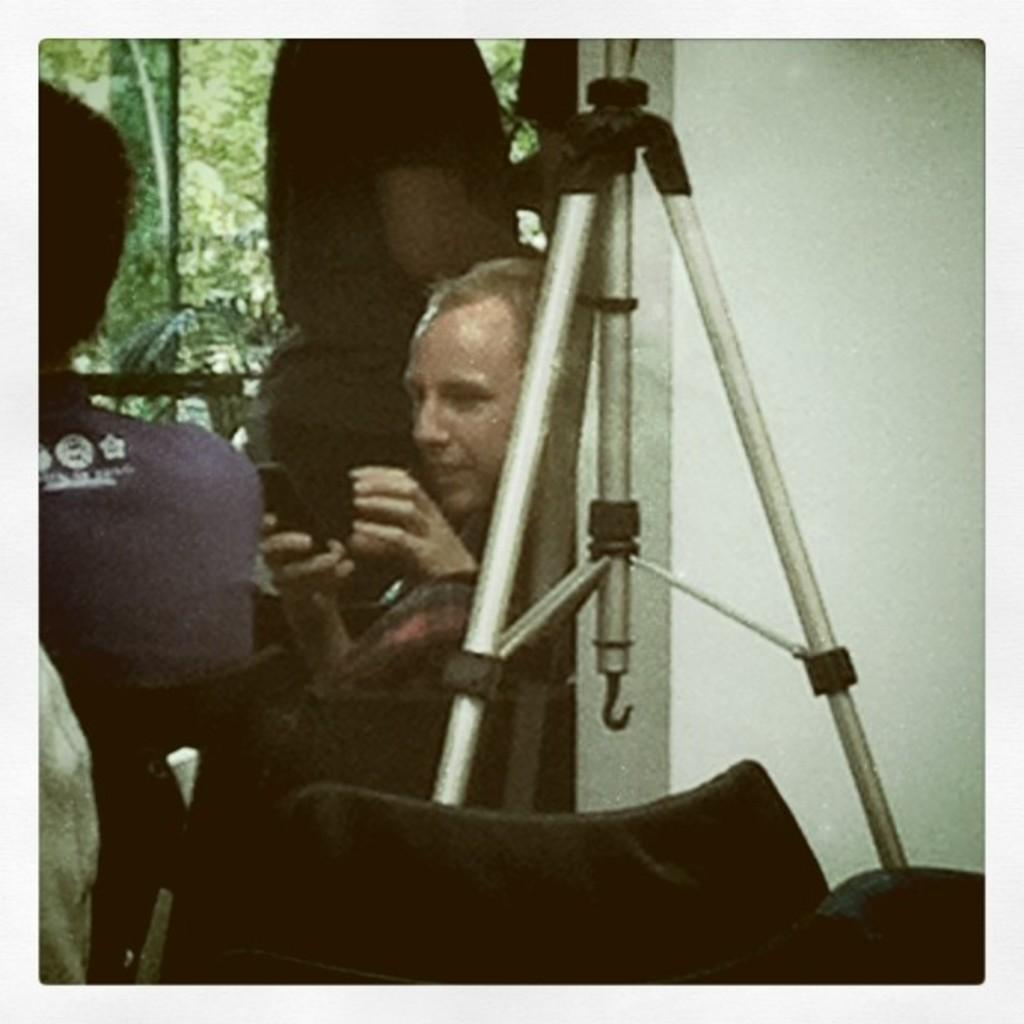What are the people in the image doing? The people in the image are sitting on chairs. What can be seen in the background of the image? There are many trees in the image. What is located at the bottom of the image? There are objects at the bottom of the image. Can you describe a specific structure in the image? There is a stand in the image. How many clams are visible on the stand in the image? There are no clams present in the image; the stand does not have any clams on it. 